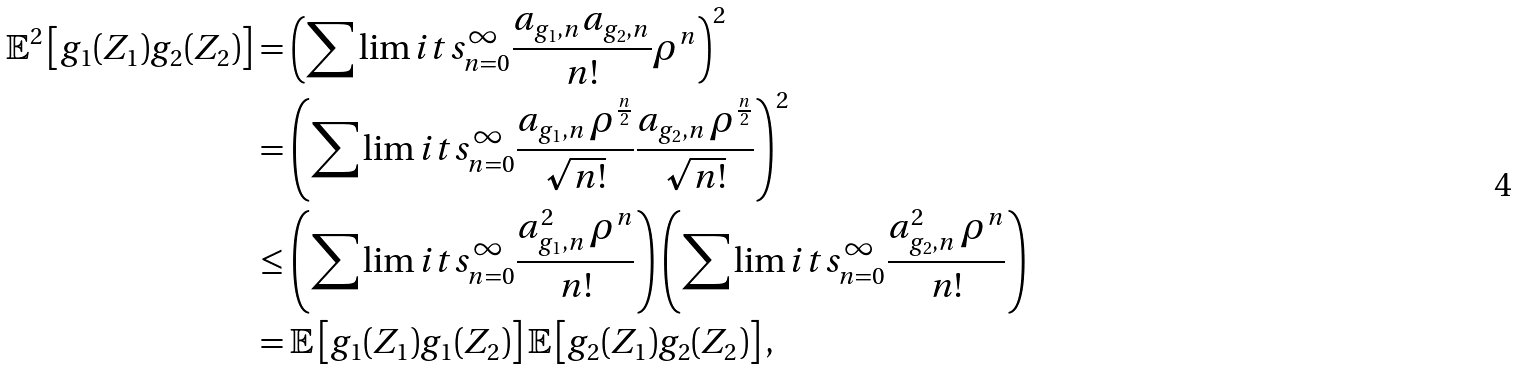Convert formula to latex. <formula><loc_0><loc_0><loc_500><loc_500>\mathbb { E } ^ { 2 } \left [ g _ { 1 } ( Z _ { 1 } ) g _ { 2 } ( Z _ { 2 } ) \right ] & = \left ( \sum \lim i t s _ { n = 0 } ^ { \infty } \frac { a _ { g _ { 1 } , n } a _ { g _ { 2 } , n } } { n ! } \rho ^ { n } \right ) ^ { 2 } \\ & = \left ( \sum \lim i t s _ { n = 0 } ^ { \infty } \frac { a _ { g _ { 1 } , n } \, \rho ^ { \frac { n } { 2 } } } { \sqrt { n ! } } \frac { a _ { g _ { 2 } , n } \, \rho ^ { \frac { n } { 2 } } } { \sqrt { n ! } } \right ) ^ { 2 } \\ & \leq \left ( \sum \lim i t s _ { n = 0 } ^ { \infty } \frac { a _ { g _ { 1 } , n } ^ { 2 } \, \rho ^ { n } } { n ! } \right ) \left ( \sum \lim i t s _ { n = 0 } ^ { \infty } \frac { a _ { g _ { 2 } , n } ^ { 2 } \, \rho ^ { n } } { n ! } \right ) \\ & = \mathbb { E } \left [ g _ { 1 } ( Z _ { 1 } ) g _ { 1 } ( Z _ { 2 } ) \right ] \mathbb { E } \left [ g _ { 2 } ( Z _ { 1 } ) g _ { 2 } ( Z _ { 2 } ) \right ] ,</formula> 